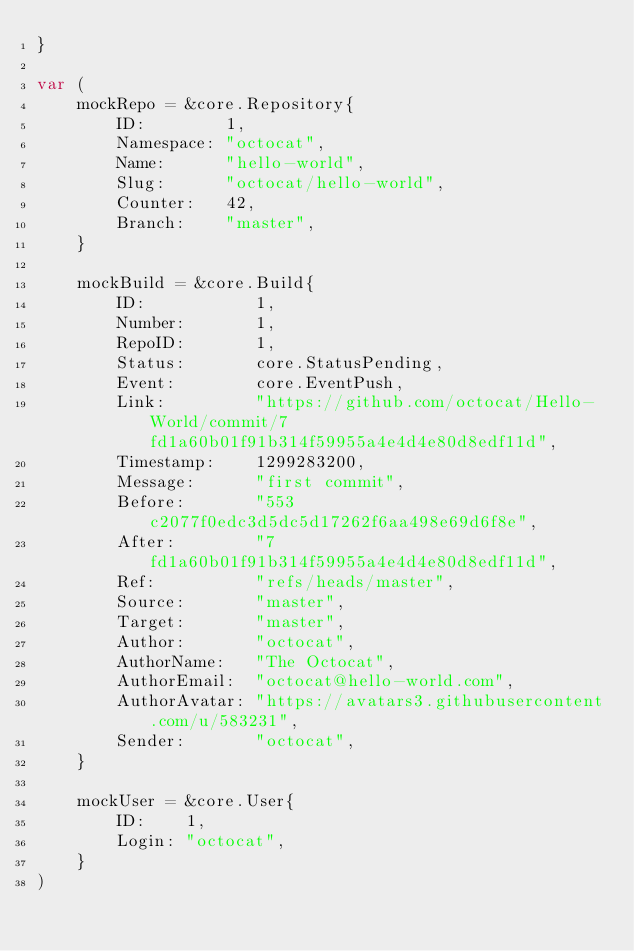Convert code to text. <code><loc_0><loc_0><loc_500><loc_500><_Go_>}

var (
	mockRepo = &core.Repository{
		ID:        1,
		Namespace: "octocat",
		Name:      "hello-world",
		Slug:      "octocat/hello-world",
		Counter:   42,
		Branch:    "master",
	}

	mockBuild = &core.Build{
		ID:           1,
		Number:       1,
		RepoID:       1,
		Status:       core.StatusPending,
		Event:        core.EventPush,
		Link:         "https://github.com/octocat/Hello-World/commit/7fd1a60b01f91b314f59955a4e4d4e80d8edf11d",
		Timestamp:    1299283200,
		Message:      "first commit",
		Before:       "553c2077f0edc3d5dc5d17262f6aa498e69d6f8e",
		After:        "7fd1a60b01f91b314f59955a4e4d4e80d8edf11d",
		Ref:          "refs/heads/master",
		Source:       "master",
		Target:       "master",
		Author:       "octocat",
		AuthorName:   "The Octocat",
		AuthorEmail:  "octocat@hello-world.com",
		AuthorAvatar: "https://avatars3.githubusercontent.com/u/583231",
		Sender:       "octocat",
	}

	mockUser = &core.User{
		ID:    1,
		Login: "octocat",
	}
)
</code> 